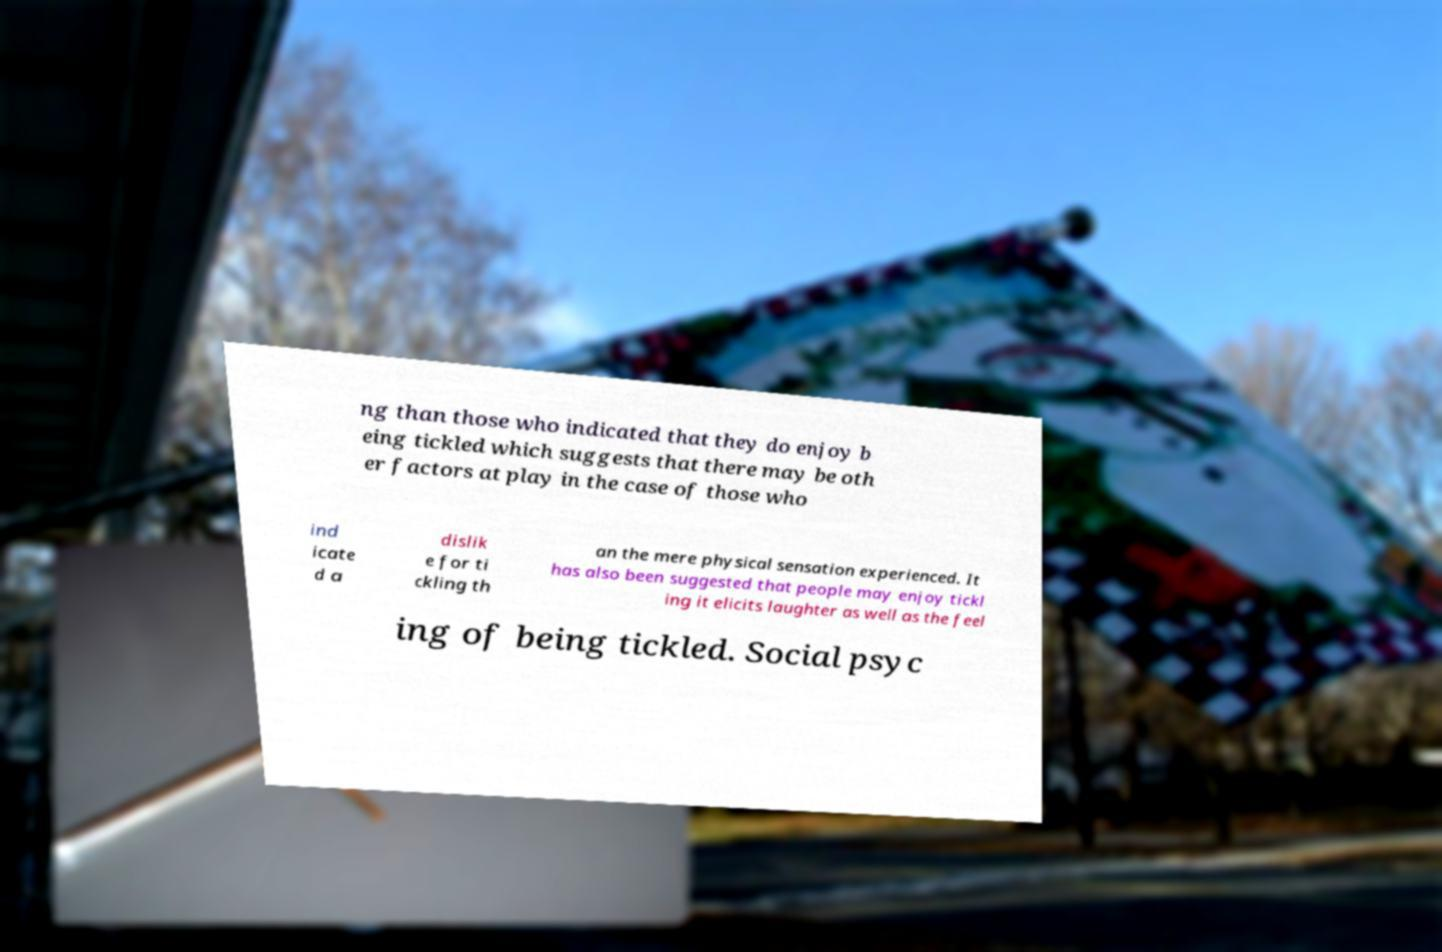Could you assist in decoding the text presented in this image and type it out clearly? ng than those who indicated that they do enjoy b eing tickled which suggests that there may be oth er factors at play in the case of those who ind icate d a dislik e for ti ckling th an the mere physical sensation experienced. It has also been suggested that people may enjoy tickl ing it elicits laughter as well as the feel ing of being tickled. Social psyc 